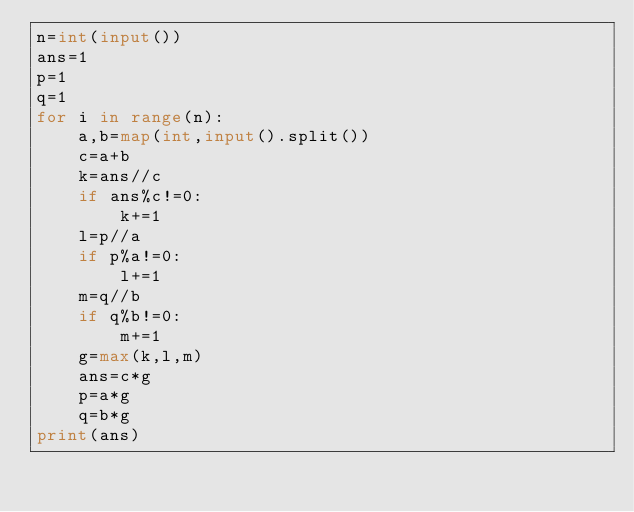<code> <loc_0><loc_0><loc_500><loc_500><_Python_>n=int(input())
ans=1
p=1
q=1
for i in range(n):
    a,b=map(int,input().split())
    c=a+b
    k=ans//c
    if ans%c!=0:
        k+=1
    l=p//a
    if p%a!=0:
        l+=1
    m=q//b
    if q%b!=0:
        m+=1
    g=max(k,l,m)
    ans=c*g
    p=a*g
    q=b*g
print(ans)
</code> 